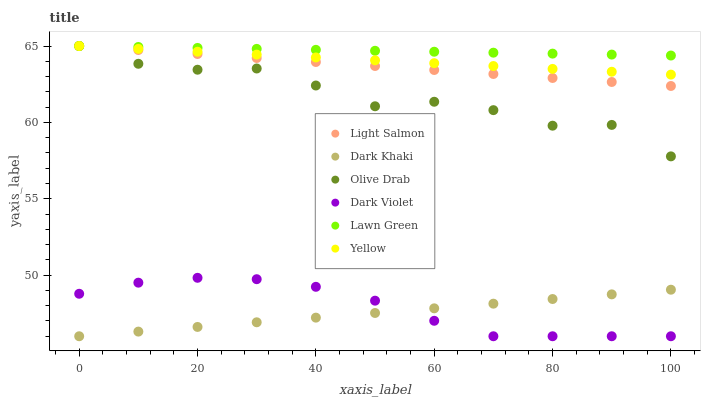Does Dark Khaki have the minimum area under the curve?
Answer yes or no. Yes. Does Lawn Green have the maximum area under the curve?
Answer yes or no. Yes. Does Light Salmon have the minimum area under the curve?
Answer yes or no. No. Does Light Salmon have the maximum area under the curve?
Answer yes or no. No. Is Yellow the smoothest?
Answer yes or no. Yes. Is Olive Drab the roughest?
Answer yes or no. Yes. Is Light Salmon the smoothest?
Answer yes or no. No. Is Light Salmon the roughest?
Answer yes or no. No. Does Dark Khaki have the lowest value?
Answer yes or no. Yes. Does Light Salmon have the lowest value?
Answer yes or no. No. Does Olive Drab have the highest value?
Answer yes or no. Yes. Does Dark Khaki have the highest value?
Answer yes or no. No. Is Dark Khaki less than Light Salmon?
Answer yes or no. Yes. Is Yellow greater than Dark Khaki?
Answer yes or no. Yes. Does Yellow intersect Olive Drab?
Answer yes or no. Yes. Is Yellow less than Olive Drab?
Answer yes or no. No. Is Yellow greater than Olive Drab?
Answer yes or no. No. Does Dark Khaki intersect Light Salmon?
Answer yes or no. No. 